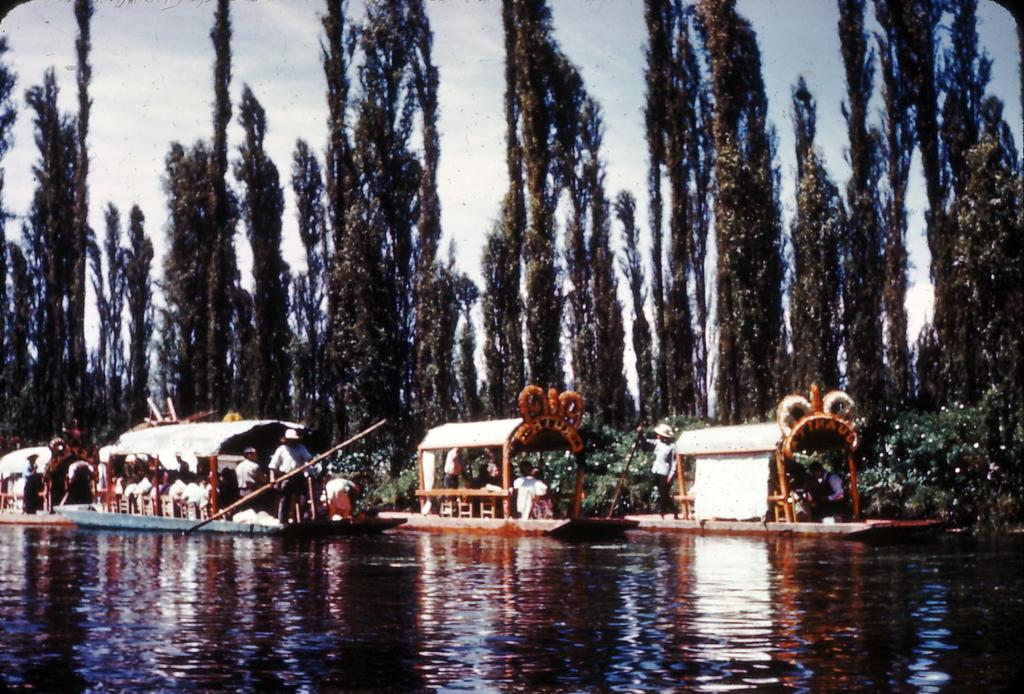What is in the water in the image? There are boats in the water in the image. Who or what is on the boats? People are on the boats. What is the man holding in the image? A man is holding an object. What can be seen in the background of the image? There are trees and the sky visible in the background. What type of note is the man reading on the boat? There is no note present in the image; the man is holding an object, but it is not specified as a note. What statement does the man make while on the boat? There is no dialogue or statement made by the man in the image. 